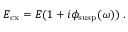Convert formula to latex. <formula><loc_0><loc_0><loc_500><loc_500>E _ { c x } = E ( 1 + i \phi _ { s u s p } ( \omega ) ) .</formula> 